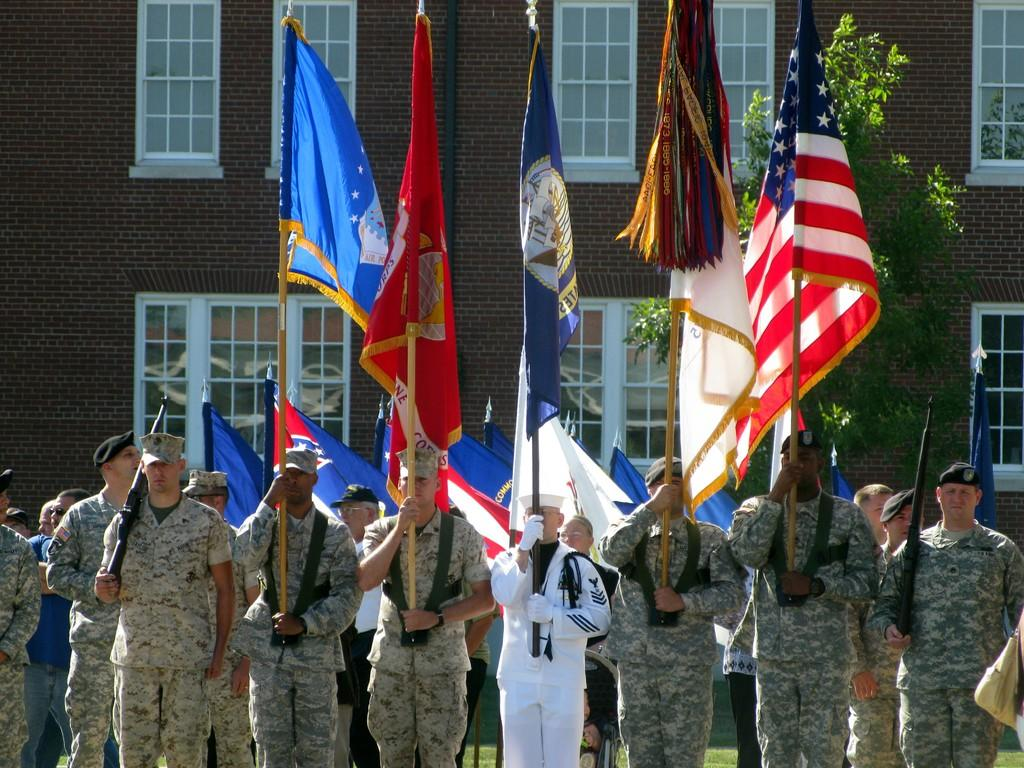How many people are in the group shown in the image? There is a group of people in the image, but the exact number is not specified. What are some people in the group holding? Some people in the group are holding flags. What can be seen in the background of the image? There is a building and trees visible in the image. Are there any architectural features visible in the image? Yes, there are windows visible in the image. Is there a beggar asking for money in the image? There is no mention of a beggar in the image, so we cannot confirm or deny their presence. How many steps are visible in the image? There is no mention of steps in the image, so we cannot determine their number. 